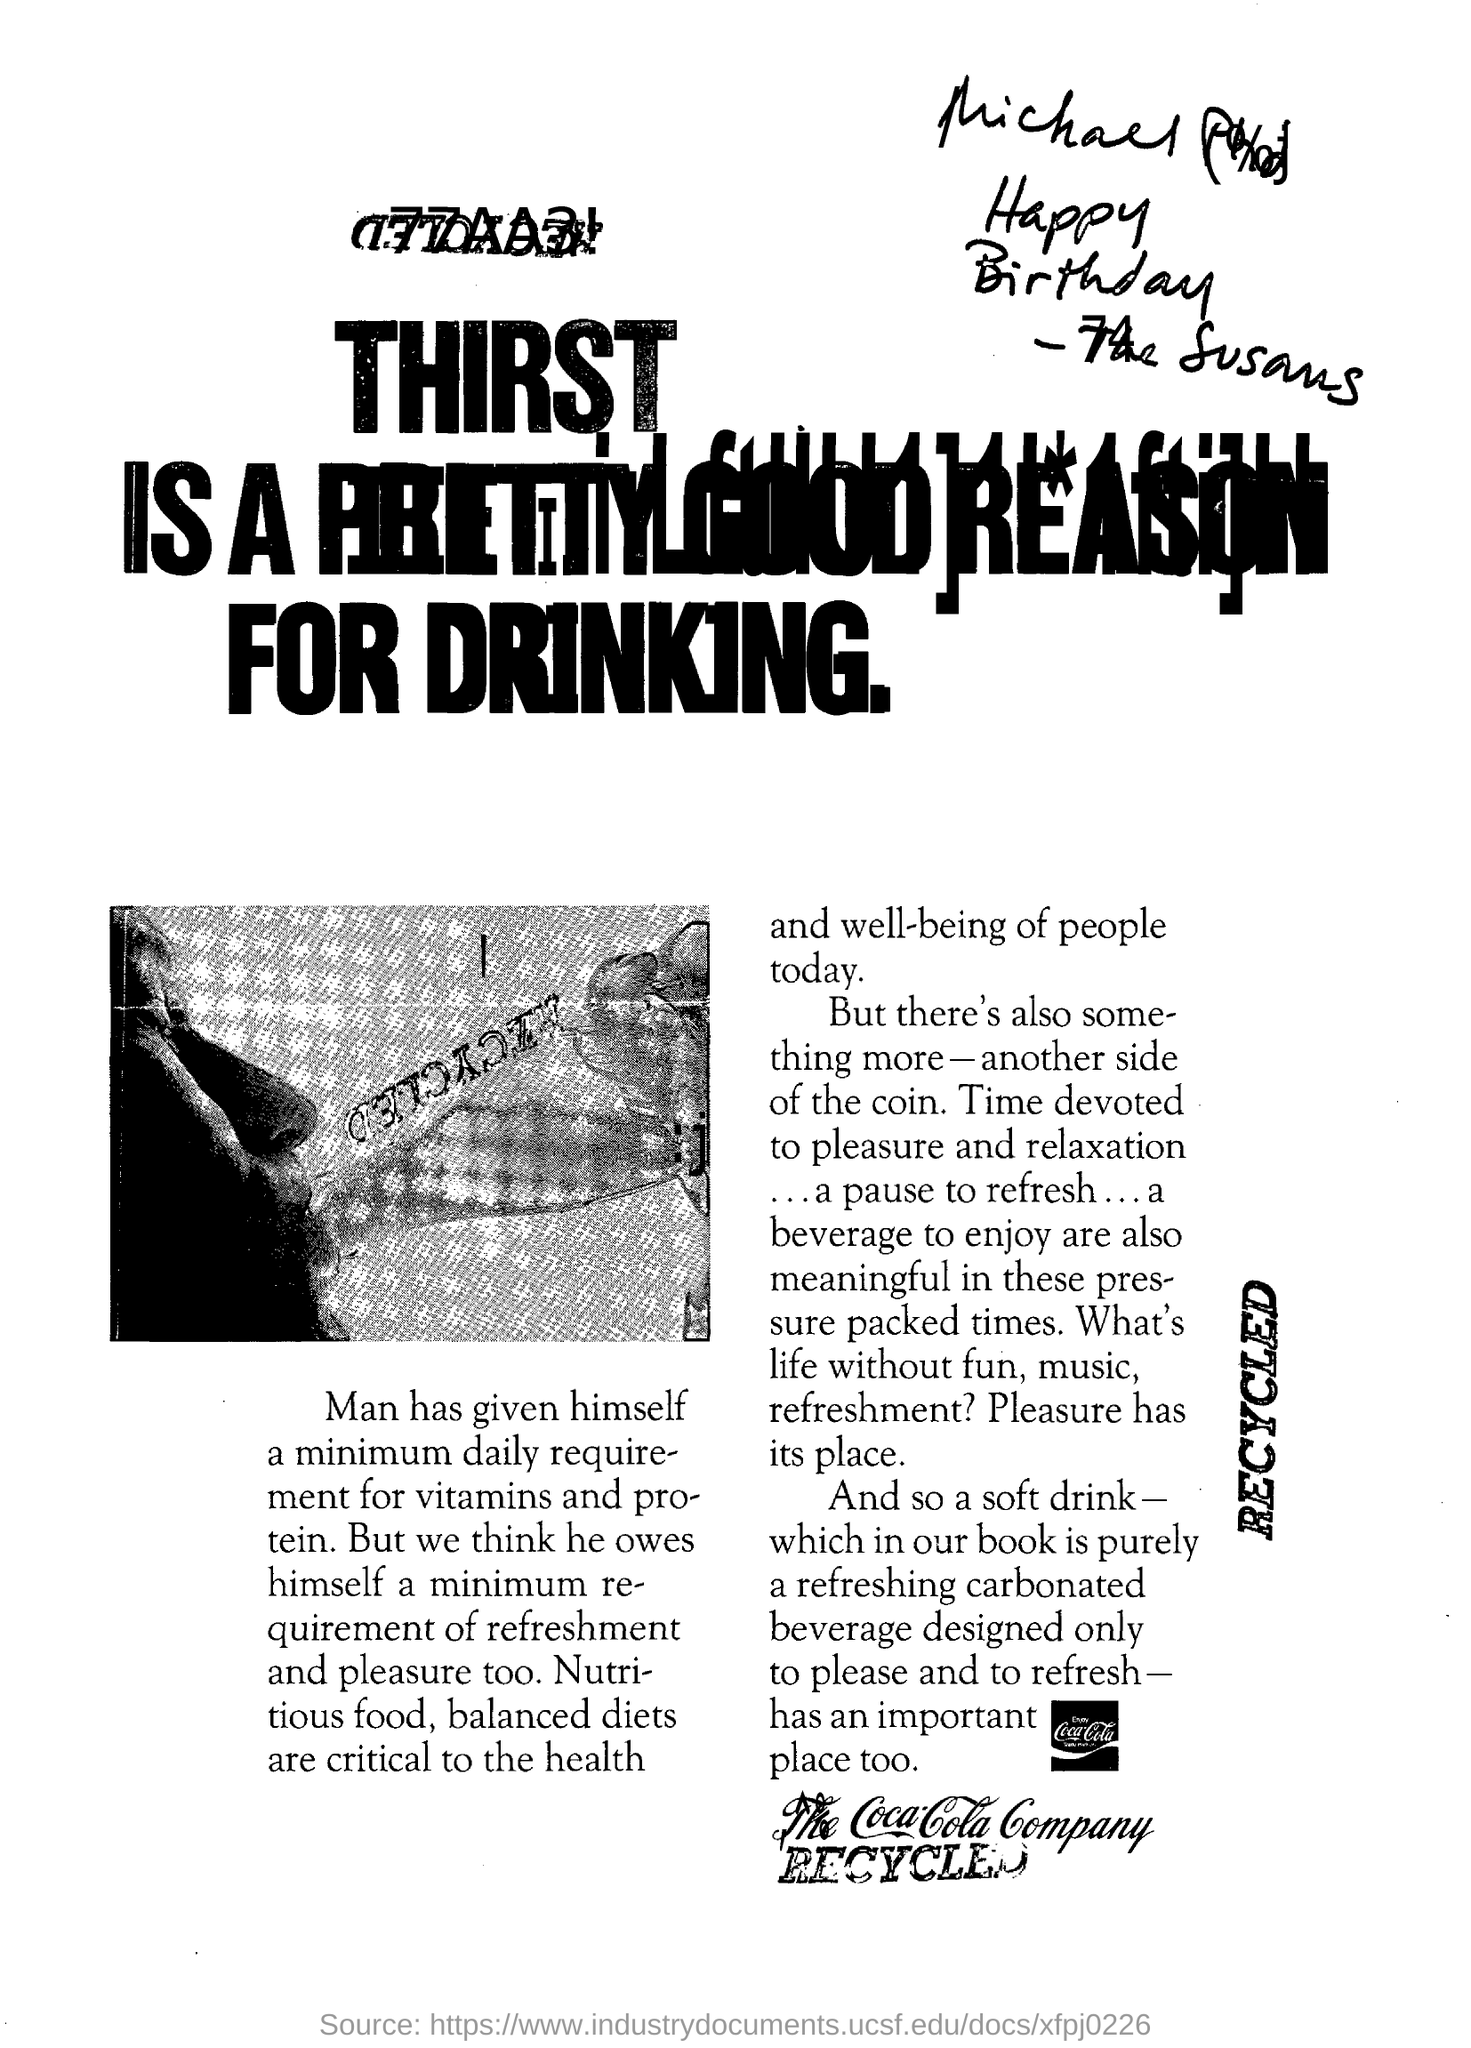Heading of the document?
Make the answer very short. THIRST IS A PRETTY GOOD REASON FOR DRINKING. What is the name of the company?
Provide a short and direct response. The Coca-Cola Company. What are critical for well-being of people today?
Keep it short and to the point. Nutritious food, balanced diets. 